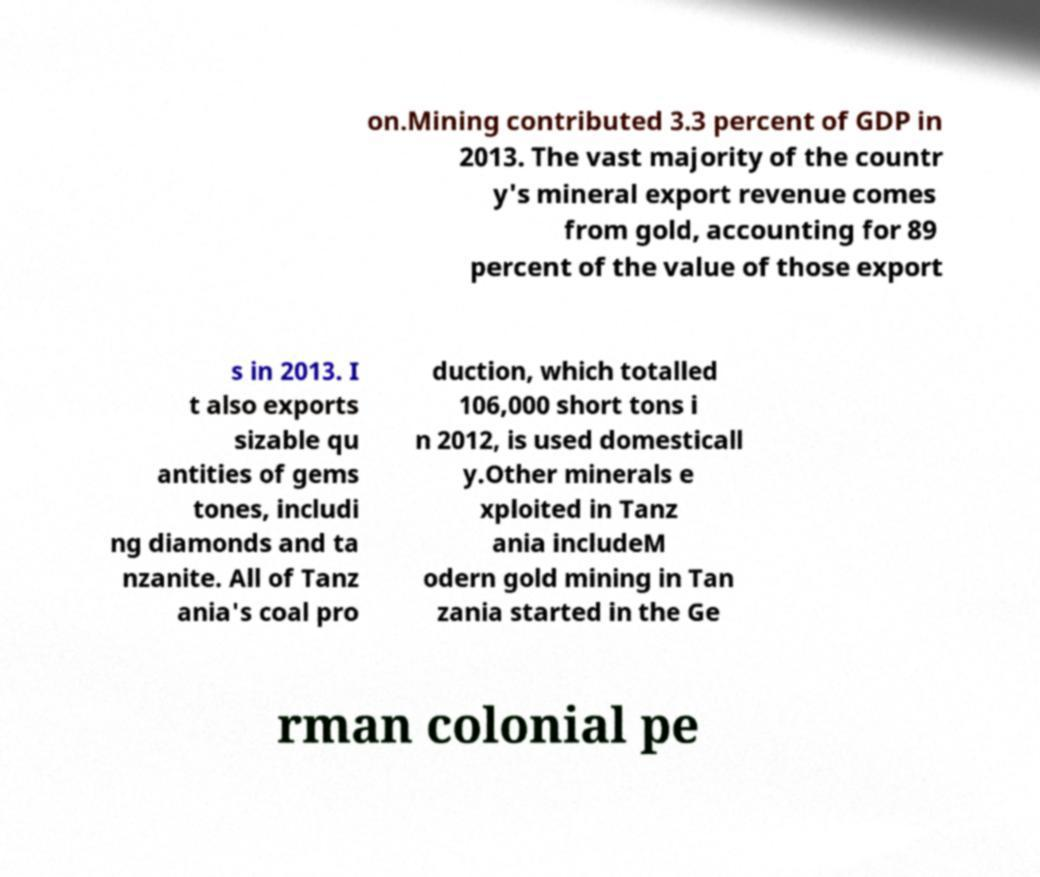Please read and relay the text visible in this image. What does it say? on.Mining contributed 3.3 percent of GDP in 2013. The vast majority of the countr y's mineral export revenue comes from gold, accounting for 89 percent of the value of those export s in 2013. I t also exports sizable qu antities of gems tones, includi ng diamonds and ta nzanite. All of Tanz ania's coal pro duction, which totalled 106,000 short tons i n 2012, is used domesticall y.Other minerals e xploited in Tanz ania includeM odern gold mining in Tan zania started in the Ge rman colonial pe 